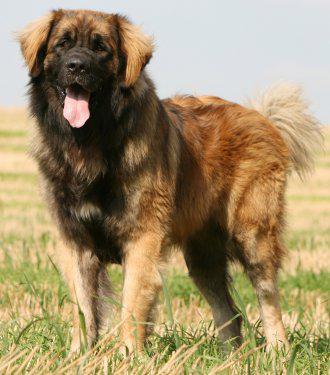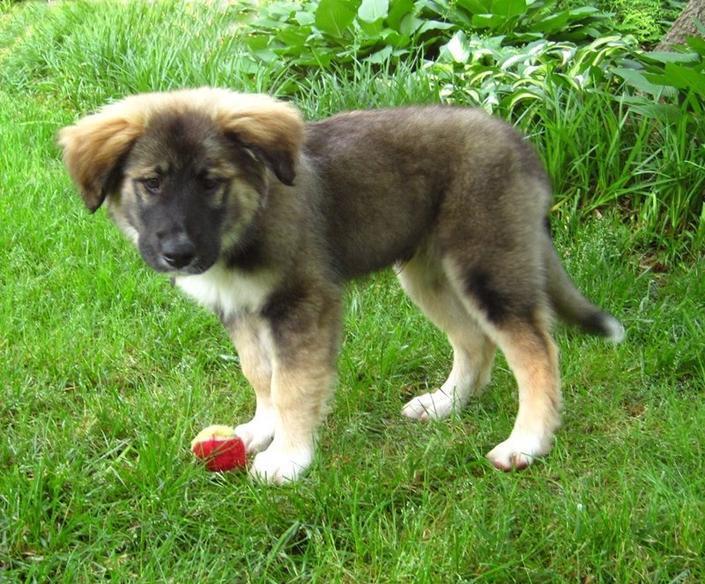The first image is the image on the left, the second image is the image on the right. Considering the images on both sides, is "The dog in the image on the right is standing in full profile facing the right." valid? Answer yes or no. No. 